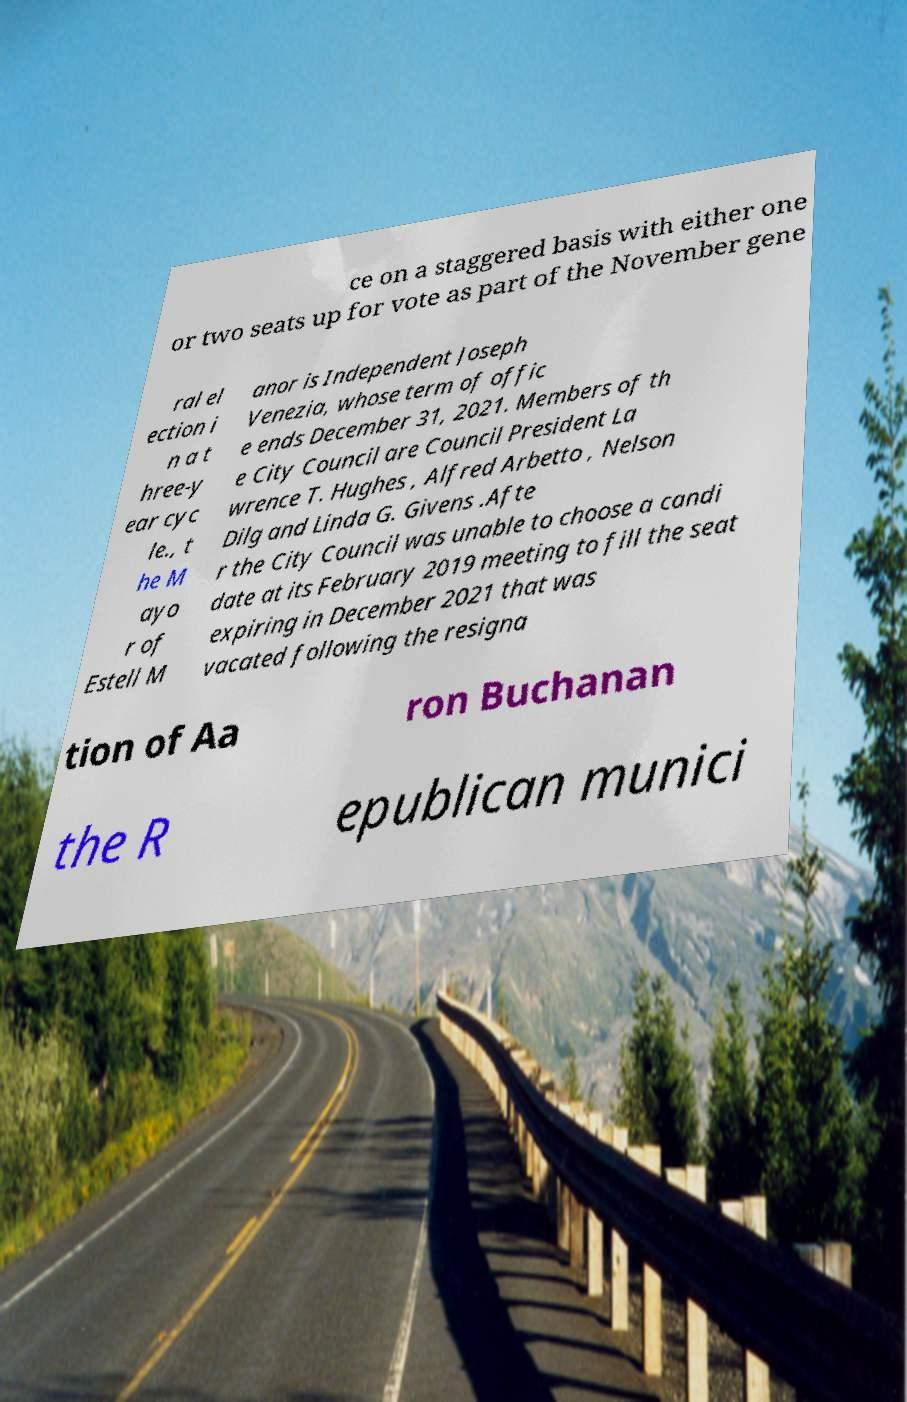Please read and relay the text visible in this image. What does it say? ce on a staggered basis with either one or two seats up for vote as part of the November gene ral el ection i n a t hree-y ear cyc le., t he M ayo r of Estell M anor is Independent Joseph Venezia, whose term of offic e ends December 31, 2021. Members of th e City Council are Council President La wrence T. Hughes , Alfred Arbetto , Nelson Dilg and Linda G. Givens .Afte r the City Council was unable to choose a candi date at its February 2019 meeting to fill the seat expiring in December 2021 that was vacated following the resigna tion of Aa ron Buchanan the R epublican munici 